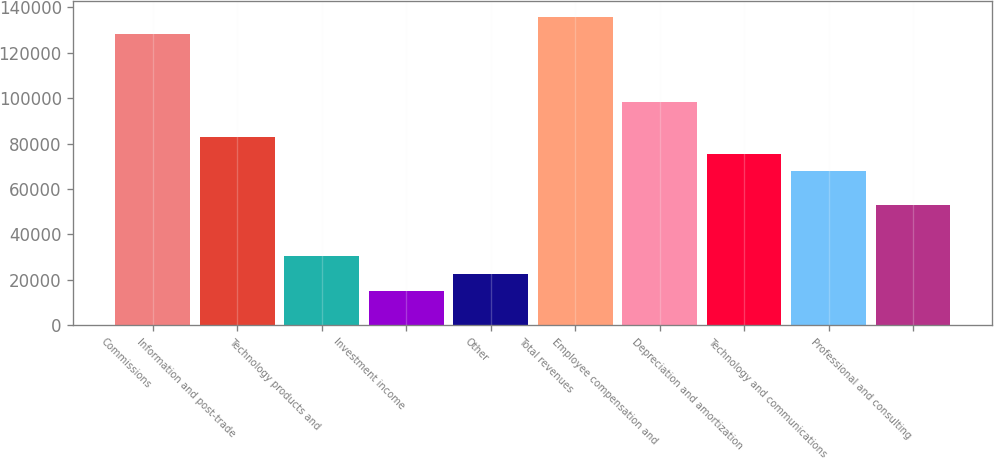<chart> <loc_0><loc_0><loc_500><loc_500><bar_chart><fcel>Commissions<fcel>Information and post-trade<fcel>Technology products and<fcel>Investment income<fcel>Other<fcel>Total revenues<fcel>Employee compensation and<fcel>Depreciation and amortization<fcel>Technology and communications<fcel>Professional and consulting<nl><fcel>128334<fcel>83040.1<fcel>30196.8<fcel>15098.7<fcel>22647.8<fcel>135883<fcel>98138.2<fcel>75491<fcel>67942<fcel>52843.9<nl></chart> 